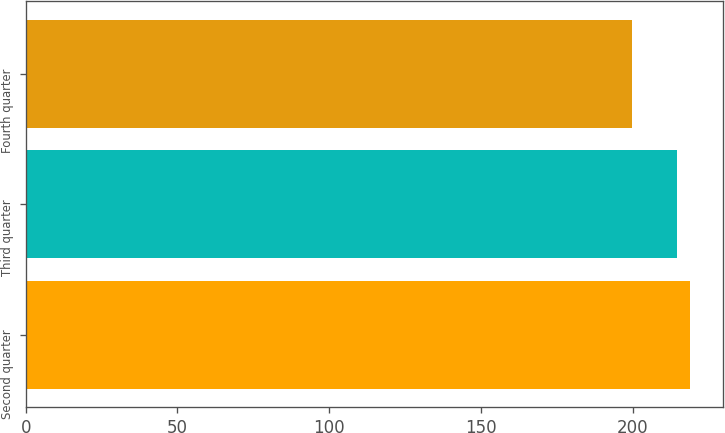Convert chart. <chart><loc_0><loc_0><loc_500><loc_500><bar_chart><fcel>Second quarter<fcel>Third quarter<fcel>Fourth quarter<nl><fcel>218.77<fcel>214.61<fcel>199.9<nl></chart> 